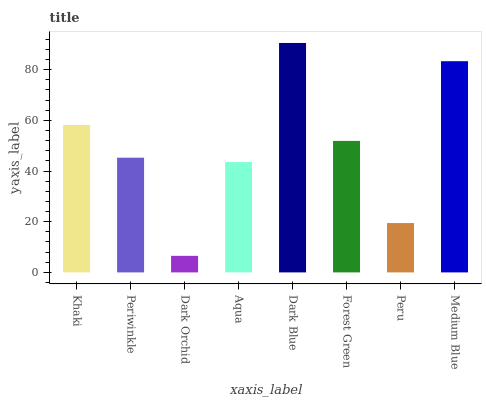Is Periwinkle the minimum?
Answer yes or no. No. Is Periwinkle the maximum?
Answer yes or no. No. Is Khaki greater than Periwinkle?
Answer yes or no. Yes. Is Periwinkle less than Khaki?
Answer yes or no. Yes. Is Periwinkle greater than Khaki?
Answer yes or no. No. Is Khaki less than Periwinkle?
Answer yes or no. No. Is Forest Green the high median?
Answer yes or no. Yes. Is Periwinkle the low median?
Answer yes or no. Yes. Is Periwinkle the high median?
Answer yes or no. No. Is Khaki the low median?
Answer yes or no. No. 